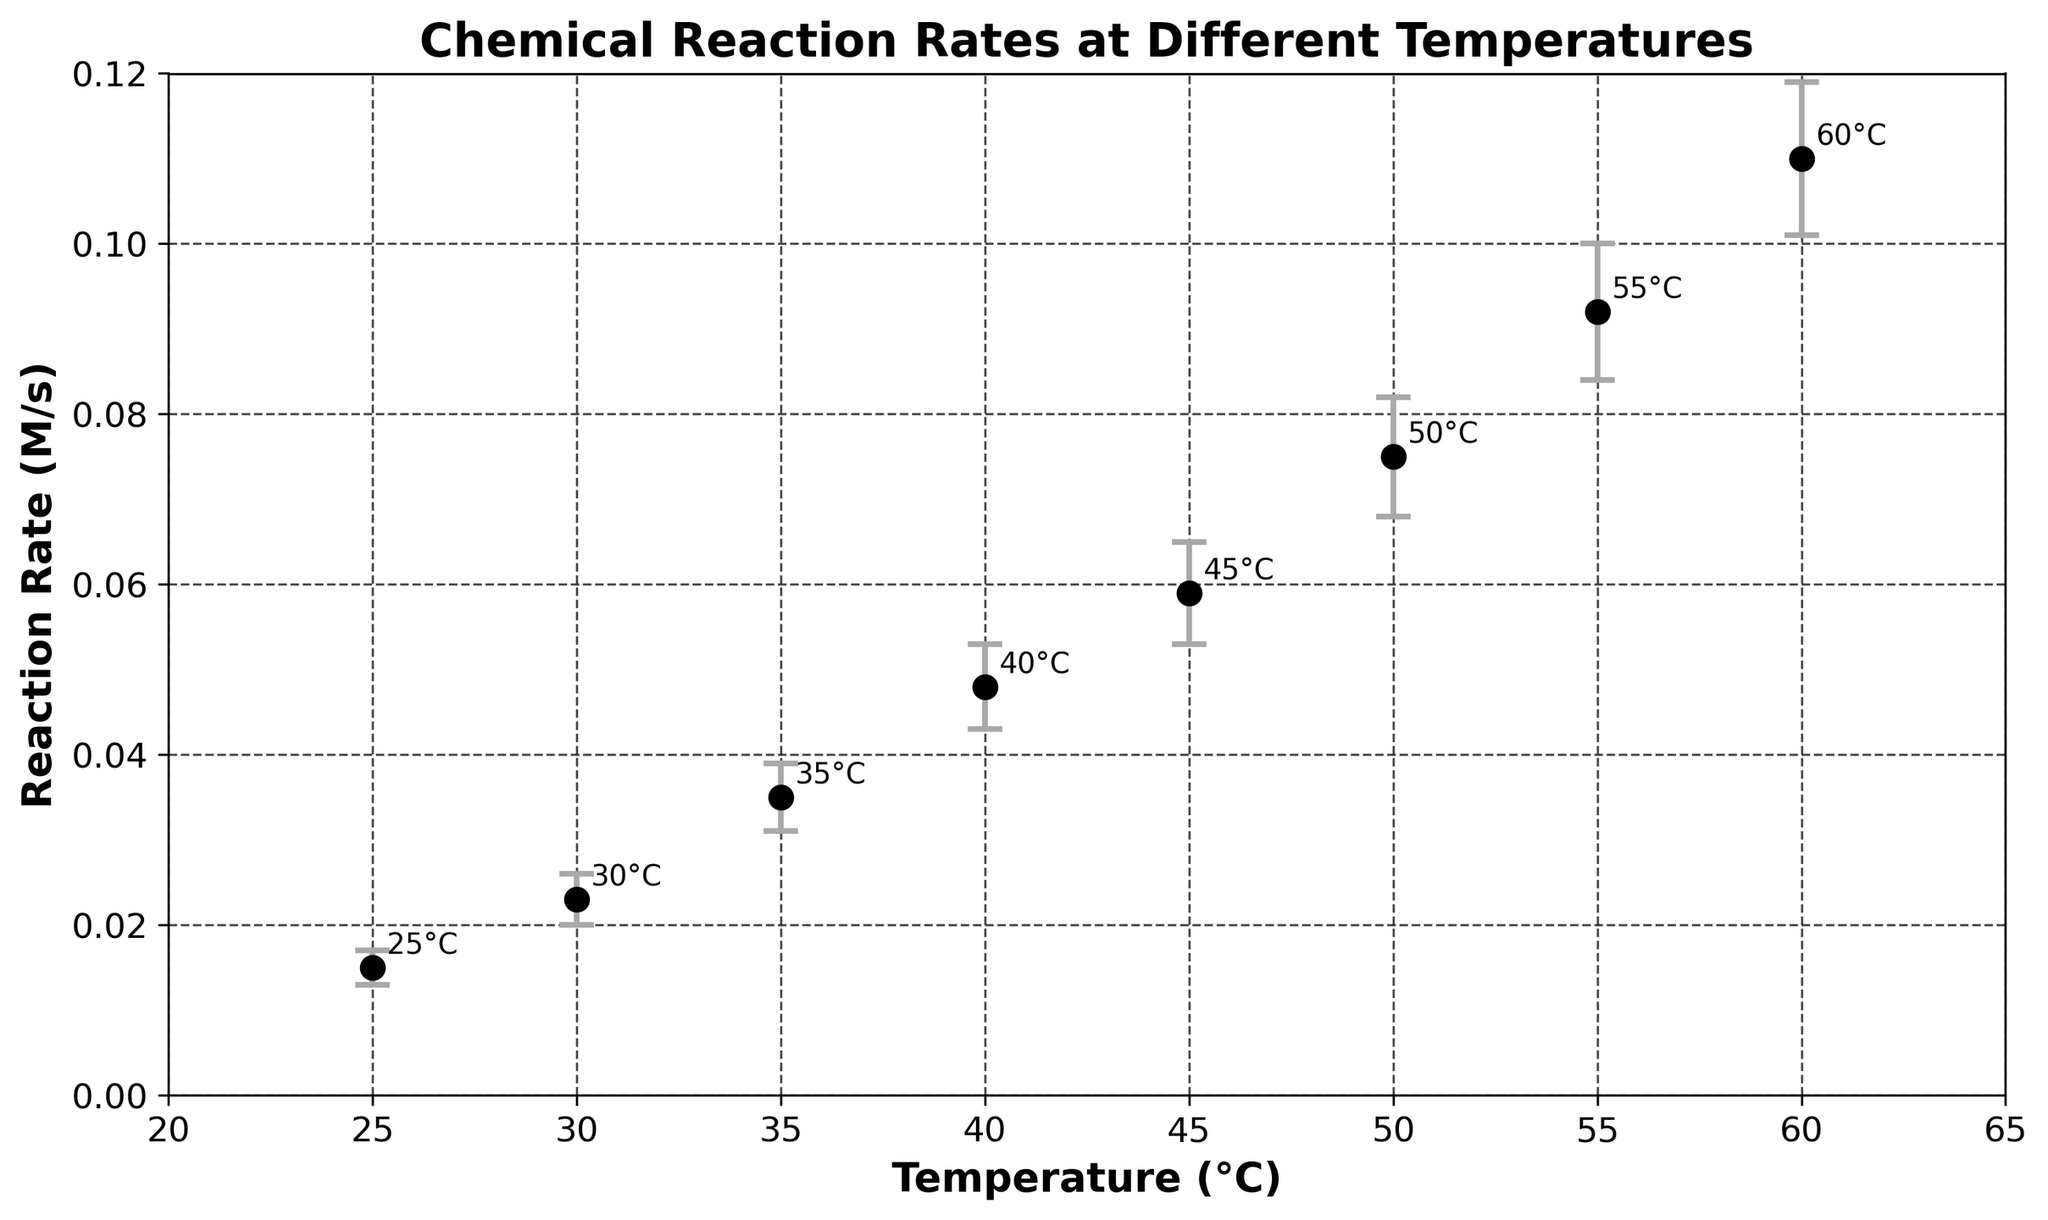What is the title of the figure? The title of the figure is typically located at the top of the graph. It summarizes the content and purpose of the plot.
Answer: Chemical Reaction Rates at Different Temperatures What are the units on the y-axis? The y-axis label explains that the units for Reaction Rate are in Moles per second (M/s).
Answer: Moles per second (M/s) How many data points are plotted on the figure? The number of data points can be determined by counting the markers on the plot. Each marker represents a different temperature. There are 8 markers in total.
Answer: 8 What is the reaction rate at 50°C? To find the reaction rate at 50°C, locate the marker on the plot that corresponds to 50°C on the x-axis and read the value on the y-axis.
Answer: 0.075 M/s Which temperature has the lowest reaction rate? Compare the reaction rates at each temperature. The lowest reaction rate corresponds to the smallest value on the y-axis.
Answer: 25°C By how much does the reaction rate increase from 30°C to 40°C? Find the reaction rates at 30°C and 40°C (0.023 M/s and 0.048 M/s respectively) and subtract the rate at 30°C from the rate at 40°C.
Answer: 0.025 M/s Which temperature interval shows the largest increase in reaction rate? Compare the differences in reaction rates between consecutive temperatures (30-25, 35-30, ..., 60-55) to determine the largest increase. The interval 60-55°C has the largest increase (0.018 M/s).
Answer: 55°C to 60°C What is the average reaction rate across all temperatures? Sum all the reaction rate values and divide by the number of data points (8). (0.015 + 0.023 + 0.035 + 0.048 + 0.059 + 0.075 + 0.092 + 0.110) / 8 ≈ 0.0571 M/s.
Answer: 0.0571 M/s Which temperature has the largest standard deviation in reaction rate? Identify the standard deviations from the plot and compare them. The largest standard deviation is at 60°C with a value of 0.009 M/s.
Answer: 60°C What is the general trend in reaction rate as temperature increases? Observing the plot, it is clear that the reaction rate increases with increasing temperature.
Answer: Increases 